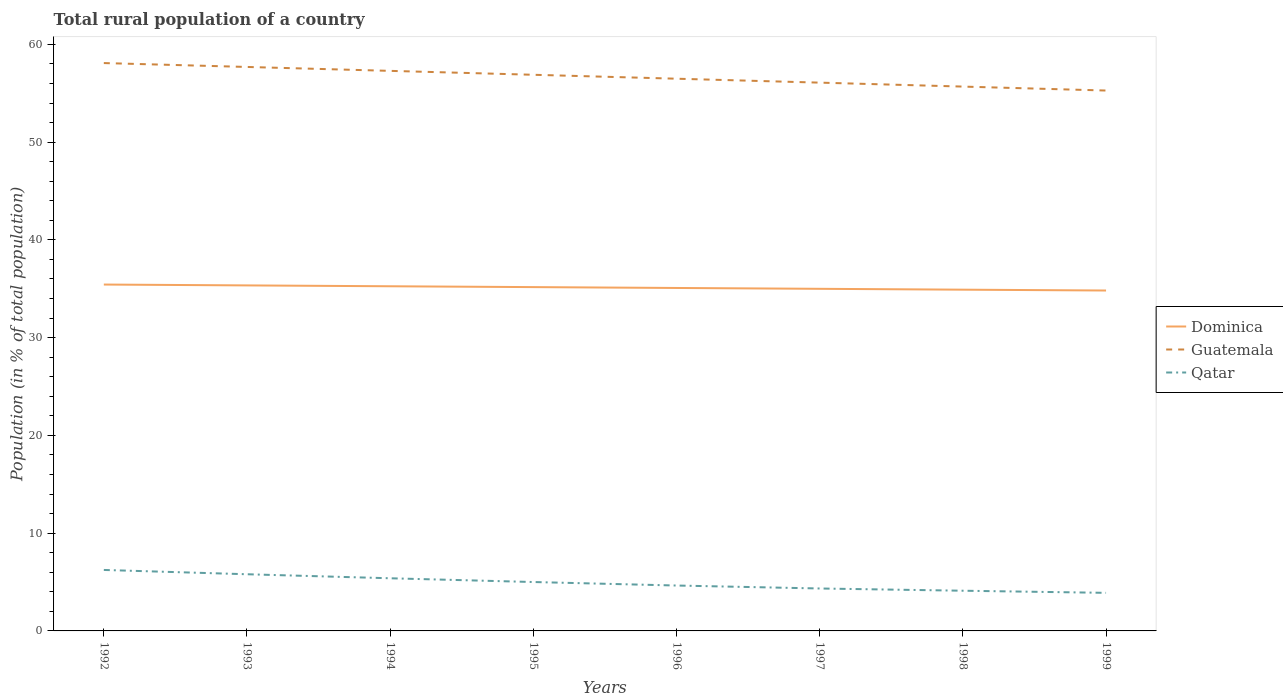How many different coloured lines are there?
Provide a short and direct response. 3. Across all years, what is the maximum rural population in Dominica?
Offer a very short reply. 34.82. In which year was the rural population in Dominica maximum?
Your answer should be compact. 1999. What is the total rural population in Dominica in the graph?
Provide a succinct answer. 0.44. What is the difference between the highest and the second highest rural population in Guatemala?
Provide a succinct answer. 2.81. What is the difference between the highest and the lowest rural population in Qatar?
Make the answer very short. 4. How many lines are there?
Give a very brief answer. 3. How many years are there in the graph?
Ensure brevity in your answer.  8. How many legend labels are there?
Make the answer very short. 3. What is the title of the graph?
Your response must be concise. Total rural population of a country. What is the label or title of the Y-axis?
Give a very brief answer. Population (in % of total population). What is the Population (in % of total population) in Dominica in 1992?
Make the answer very short. 35.43. What is the Population (in % of total population) in Guatemala in 1992?
Ensure brevity in your answer.  58.09. What is the Population (in % of total population) in Qatar in 1992?
Offer a very short reply. 6.24. What is the Population (in % of total population) in Dominica in 1993?
Provide a short and direct response. 35.34. What is the Population (in % of total population) in Guatemala in 1993?
Offer a terse response. 57.69. What is the Population (in % of total population) in Qatar in 1993?
Your answer should be compact. 5.8. What is the Population (in % of total population) in Dominica in 1994?
Make the answer very short. 35.26. What is the Population (in % of total population) of Guatemala in 1994?
Keep it short and to the point. 57.29. What is the Population (in % of total population) in Qatar in 1994?
Keep it short and to the point. 5.39. What is the Population (in % of total population) of Dominica in 1995?
Provide a succinct answer. 35.17. What is the Population (in % of total population) of Guatemala in 1995?
Offer a terse response. 56.89. What is the Population (in % of total population) in Qatar in 1995?
Make the answer very short. 5. What is the Population (in % of total population) of Dominica in 1996?
Provide a short and direct response. 35.08. What is the Population (in % of total population) of Guatemala in 1996?
Offer a very short reply. 56.49. What is the Population (in % of total population) of Qatar in 1996?
Give a very brief answer. 4.64. What is the Population (in % of total population) in Dominica in 1997?
Offer a very short reply. 34.99. What is the Population (in % of total population) in Guatemala in 1997?
Give a very brief answer. 56.09. What is the Population (in % of total population) in Qatar in 1997?
Your answer should be very brief. 4.34. What is the Population (in % of total population) in Dominica in 1998?
Keep it short and to the point. 34.91. What is the Population (in % of total population) in Guatemala in 1998?
Give a very brief answer. 55.68. What is the Population (in % of total population) of Qatar in 1998?
Offer a terse response. 4.11. What is the Population (in % of total population) in Dominica in 1999?
Offer a terse response. 34.82. What is the Population (in % of total population) of Guatemala in 1999?
Give a very brief answer. 55.28. What is the Population (in % of total population) of Qatar in 1999?
Your answer should be very brief. 3.9. Across all years, what is the maximum Population (in % of total population) in Dominica?
Provide a short and direct response. 35.43. Across all years, what is the maximum Population (in % of total population) in Guatemala?
Your answer should be very brief. 58.09. Across all years, what is the maximum Population (in % of total population) in Qatar?
Make the answer very short. 6.24. Across all years, what is the minimum Population (in % of total population) of Dominica?
Your answer should be compact. 34.82. Across all years, what is the minimum Population (in % of total population) in Guatemala?
Make the answer very short. 55.28. Across all years, what is the minimum Population (in % of total population) in Qatar?
Ensure brevity in your answer.  3.9. What is the total Population (in % of total population) of Dominica in the graph?
Make the answer very short. 281.01. What is the total Population (in % of total population) in Guatemala in the graph?
Keep it short and to the point. 453.49. What is the total Population (in % of total population) in Qatar in the graph?
Provide a short and direct response. 39.41. What is the difference between the Population (in % of total population) in Dominica in 1992 and that in 1993?
Your answer should be very brief. 0.09. What is the difference between the Population (in % of total population) of Guatemala in 1992 and that in 1993?
Your answer should be compact. 0.4. What is the difference between the Population (in % of total population) of Qatar in 1992 and that in 1993?
Provide a succinct answer. 0.44. What is the difference between the Population (in % of total population) in Dominica in 1992 and that in 1994?
Provide a succinct answer. 0.17. What is the difference between the Population (in % of total population) of Guatemala in 1992 and that in 1994?
Provide a short and direct response. 0.8. What is the difference between the Population (in % of total population) of Qatar in 1992 and that in 1994?
Your answer should be very brief. 0.85. What is the difference between the Population (in % of total population) of Dominica in 1992 and that in 1995?
Offer a terse response. 0.26. What is the difference between the Population (in % of total population) in Guatemala in 1992 and that in 1995?
Provide a short and direct response. 1.2. What is the difference between the Population (in % of total population) of Qatar in 1992 and that in 1995?
Keep it short and to the point. 1.24. What is the difference between the Population (in % of total population) in Dominica in 1992 and that in 1996?
Your answer should be very brief. 0.35. What is the difference between the Population (in % of total population) in Guatemala in 1992 and that in 1996?
Offer a terse response. 1.6. What is the difference between the Population (in % of total population) of Qatar in 1992 and that in 1996?
Keep it short and to the point. 1.59. What is the difference between the Population (in % of total population) of Dominica in 1992 and that in 1997?
Offer a terse response. 0.44. What is the difference between the Population (in % of total population) of Guatemala in 1992 and that in 1997?
Offer a terse response. 2. What is the difference between the Population (in % of total population) of Qatar in 1992 and that in 1997?
Give a very brief answer. 1.9. What is the difference between the Population (in % of total population) of Dominica in 1992 and that in 1998?
Give a very brief answer. 0.52. What is the difference between the Population (in % of total population) in Guatemala in 1992 and that in 1998?
Ensure brevity in your answer.  2.41. What is the difference between the Population (in % of total population) in Qatar in 1992 and that in 1998?
Your answer should be compact. 2.12. What is the difference between the Population (in % of total population) in Dominica in 1992 and that in 1999?
Give a very brief answer. 0.61. What is the difference between the Population (in % of total population) in Guatemala in 1992 and that in 1999?
Make the answer very short. 2.81. What is the difference between the Population (in % of total population) in Qatar in 1992 and that in 1999?
Provide a short and direct response. 2.34. What is the difference between the Population (in % of total population) in Dominica in 1993 and that in 1994?
Keep it short and to the point. 0.09. What is the difference between the Population (in % of total population) in Qatar in 1993 and that in 1994?
Make the answer very short. 0.41. What is the difference between the Population (in % of total population) of Dominica in 1993 and that in 1995?
Make the answer very short. 0.17. What is the difference between the Population (in % of total population) in Qatar in 1993 and that in 1995?
Your answer should be very brief. 0.8. What is the difference between the Population (in % of total population) in Dominica in 1993 and that in 1996?
Your answer should be very brief. 0.26. What is the difference between the Population (in % of total population) of Guatemala in 1993 and that in 1996?
Give a very brief answer. 1.2. What is the difference between the Population (in % of total population) of Qatar in 1993 and that in 1996?
Your answer should be compact. 1.15. What is the difference between the Population (in % of total population) of Dominica in 1993 and that in 1997?
Provide a short and direct response. 0.35. What is the difference between the Population (in % of total population) in Guatemala in 1993 and that in 1997?
Offer a terse response. 1.6. What is the difference between the Population (in % of total population) in Qatar in 1993 and that in 1997?
Provide a succinct answer. 1.46. What is the difference between the Population (in % of total population) in Dominica in 1993 and that in 1998?
Provide a succinct answer. 0.44. What is the difference between the Population (in % of total population) in Guatemala in 1993 and that in 1998?
Ensure brevity in your answer.  2.01. What is the difference between the Population (in % of total population) of Qatar in 1993 and that in 1998?
Ensure brevity in your answer.  1.69. What is the difference between the Population (in % of total population) of Dominica in 1993 and that in 1999?
Ensure brevity in your answer.  0.52. What is the difference between the Population (in % of total population) of Guatemala in 1993 and that in 1999?
Your answer should be compact. 2.41. What is the difference between the Population (in % of total population) in Qatar in 1993 and that in 1999?
Give a very brief answer. 1.9. What is the difference between the Population (in % of total population) in Dominica in 1994 and that in 1995?
Offer a very short reply. 0.09. What is the difference between the Population (in % of total population) in Guatemala in 1994 and that in 1995?
Offer a terse response. 0.4. What is the difference between the Population (in % of total population) in Qatar in 1994 and that in 1995?
Provide a succinct answer. 0.38. What is the difference between the Population (in % of total population) of Dominica in 1994 and that in 1996?
Make the answer very short. 0.17. What is the difference between the Population (in % of total population) of Guatemala in 1994 and that in 1996?
Offer a terse response. 0.8. What is the difference between the Population (in % of total population) of Qatar in 1994 and that in 1996?
Offer a very short reply. 0.74. What is the difference between the Population (in % of total population) in Dominica in 1994 and that in 1997?
Your response must be concise. 0.26. What is the difference between the Population (in % of total population) of Guatemala in 1994 and that in 1997?
Provide a short and direct response. 1.2. What is the difference between the Population (in % of total population) in Qatar in 1994 and that in 1997?
Offer a very short reply. 1.04. What is the difference between the Population (in % of total population) in Dominica in 1994 and that in 1998?
Provide a short and direct response. 0.35. What is the difference between the Population (in % of total population) in Guatemala in 1994 and that in 1998?
Your response must be concise. 1.61. What is the difference between the Population (in % of total population) of Qatar in 1994 and that in 1998?
Your answer should be compact. 1.27. What is the difference between the Population (in % of total population) in Dominica in 1994 and that in 1999?
Provide a short and direct response. 0.43. What is the difference between the Population (in % of total population) of Guatemala in 1994 and that in 1999?
Keep it short and to the point. 2.01. What is the difference between the Population (in % of total population) of Qatar in 1994 and that in 1999?
Offer a very short reply. 1.49. What is the difference between the Population (in % of total population) of Dominica in 1995 and that in 1996?
Provide a succinct answer. 0.09. What is the difference between the Population (in % of total population) of Guatemala in 1995 and that in 1996?
Offer a very short reply. 0.4. What is the difference between the Population (in % of total population) of Qatar in 1995 and that in 1996?
Provide a succinct answer. 0.36. What is the difference between the Population (in % of total population) in Dominica in 1995 and that in 1997?
Your answer should be very brief. 0.17. What is the difference between the Population (in % of total population) in Guatemala in 1995 and that in 1997?
Your response must be concise. 0.8. What is the difference between the Population (in % of total population) in Qatar in 1995 and that in 1997?
Offer a very short reply. 0.66. What is the difference between the Population (in % of total population) of Dominica in 1995 and that in 1998?
Make the answer very short. 0.26. What is the difference between the Population (in % of total population) in Guatemala in 1995 and that in 1998?
Provide a short and direct response. 1.21. What is the difference between the Population (in % of total population) in Qatar in 1995 and that in 1998?
Offer a terse response. 0.89. What is the difference between the Population (in % of total population) of Dominica in 1995 and that in 1999?
Keep it short and to the point. 0.35. What is the difference between the Population (in % of total population) of Guatemala in 1995 and that in 1999?
Give a very brief answer. 1.61. What is the difference between the Population (in % of total population) in Qatar in 1995 and that in 1999?
Your response must be concise. 1.11. What is the difference between the Population (in % of total population) of Dominica in 1996 and that in 1997?
Offer a terse response. 0.09. What is the difference between the Population (in % of total population) of Guatemala in 1996 and that in 1997?
Keep it short and to the point. 0.4. What is the difference between the Population (in % of total population) of Qatar in 1996 and that in 1997?
Provide a succinct answer. 0.3. What is the difference between the Population (in % of total population) in Dominica in 1996 and that in 1998?
Your response must be concise. 0.17. What is the difference between the Population (in % of total population) in Guatemala in 1996 and that in 1998?
Offer a terse response. 0.81. What is the difference between the Population (in % of total population) of Qatar in 1996 and that in 1998?
Offer a very short reply. 0.53. What is the difference between the Population (in % of total population) of Dominica in 1996 and that in 1999?
Your response must be concise. 0.26. What is the difference between the Population (in % of total population) in Guatemala in 1996 and that in 1999?
Offer a terse response. 1.21. What is the difference between the Population (in % of total population) in Qatar in 1996 and that in 1999?
Your answer should be very brief. 0.75. What is the difference between the Population (in % of total population) in Dominica in 1997 and that in 1998?
Give a very brief answer. 0.09. What is the difference between the Population (in % of total population) in Guatemala in 1997 and that in 1998?
Make the answer very short. 0.4. What is the difference between the Population (in % of total population) of Qatar in 1997 and that in 1998?
Keep it short and to the point. 0.23. What is the difference between the Population (in % of total population) of Dominica in 1997 and that in 1999?
Keep it short and to the point. 0.17. What is the difference between the Population (in % of total population) of Guatemala in 1997 and that in 1999?
Keep it short and to the point. 0.81. What is the difference between the Population (in % of total population) in Qatar in 1997 and that in 1999?
Offer a very short reply. 0.45. What is the difference between the Population (in % of total population) of Dominica in 1998 and that in 1999?
Offer a terse response. 0.09. What is the difference between the Population (in % of total population) in Guatemala in 1998 and that in 1999?
Ensure brevity in your answer.  0.4. What is the difference between the Population (in % of total population) in Qatar in 1998 and that in 1999?
Offer a very short reply. 0.22. What is the difference between the Population (in % of total population) in Dominica in 1992 and the Population (in % of total population) in Guatemala in 1993?
Provide a succinct answer. -22.26. What is the difference between the Population (in % of total population) in Dominica in 1992 and the Population (in % of total population) in Qatar in 1993?
Ensure brevity in your answer.  29.63. What is the difference between the Population (in % of total population) in Guatemala in 1992 and the Population (in % of total population) in Qatar in 1993?
Offer a terse response. 52.29. What is the difference between the Population (in % of total population) in Dominica in 1992 and the Population (in % of total population) in Guatemala in 1994?
Provide a succinct answer. -21.86. What is the difference between the Population (in % of total population) of Dominica in 1992 and the Population (in % of total population) of Qatar in 1994?
Your answer should be compact. 30.05. What is the difference between the Population (in % of total population) in Guatemala in 1992 and the Population (in % of total population) in Qatar in 1994?
Give a very brief answer. 52.7. What is the difference between the Population (in % of total population) of Dominica in 1992 and the Population (in % of total population) of Guatemala in 1995?
Make the answer very short. -21.46. What is the difference between the Population (in % of total population) of Dominica in 1992 and the Population (in % of total population) of Qatar in 1995?
Your response must be concise. 30.43. What is the difference between the Population (in % of total population) in Guatemala in 1992 and the Population (in % of total population) in Qatar in 1995?
Your response must be concise. 53.09. What is the difference between the Population (in % of total population) in Dominica in 1992 and the Population (in % of total population) in Guatemala in 1996?
Make the answer very short. -21.06. What is the difference between the Population (in % of total population) in Dominica in 1992 and the Population (in % of total population) in Qatar in 1996?
Offer a very short reply. 30.79. What is the difference between the Population (in % of total population) in Guatemala in 1992 and the Population (in % of total population) in Qatar in 1996?
Offer a very short reply. 53.44. What is the difference between the Population (in % of total population) of Dominica in 1992 and the Population (in % of total population) of Guatemala in 1997?
Ensure brevity in your answer.  -20.66. What is the difference between the Population (in % of total population) in Dominica in 1992 and the Population (in % of total population) in Qatar in 1997?
Your answer should be very brief. 31.09. What is the difference between the Population (in % of total population) in Guatemala in 1992 and the Population (in % of total population) in Qatar in 1997?
Provide a succinct answer. 53.75. What is the difference between the Population (in % of total population) of Dominica in 1992 and the Population (in % of total population) of Guatemala in 1998?
Offer a very short reply. -20.25. What is the difference between the Population (in % of total population) of Dominica in 1992 and the Population (in % of total population) of Qatar in 1998?
Offer a terse response. 31.32. What is the difference between the Population (in % of total population) in Guatemala in 1992 and the Population (in % of total population) in Qatar in 1998?
Ensure brevity in your answer.  53.98. What is the difference between the Population (in % of total population) of Dominica in 1992 and the Population (in % of total population) of Guatemala in 1999?
Provide a short and direct response. -19.85. What is the difference between the Population (in % of total population) of Dominica in 1992 and the Population (in % of total population) of Qatar in 1999?
Your answer should be very brief. 31.54. What is the difference between the Population (in % of total population) in Guatemala in 1992 and the Population (in % of total population) in Qatar in 1999?
Offer a terse response. 54.19. What is the difference between the Population (in % of total population) in Dominica in 1993 and the Population (in % of total population) in Guatemala in 1994?
Your answer should be very brief. -21.95. What is the difference between the Population (in % of total population) of Dominica in 1993 and the Population (in % of total population) of Qatar in 1994?
Your response must be concise. 29.96. What is the difference between the Population (in % of total population) of Guatemala in 1993 and the Population (in % of total population) of Qatar in 1994?
Provide a short and direct response. 52.3. What is the difference between the Population (in % of total population) of Dominica in 1993 and the Population (in % of total population) of Guatemala in 1995?
Give a very brief answer. -21.55. What is the difference between the Population (in % of total population) in Dominica in 1993 and the Population (in % of total population) in Qatar in 1995?
Ensure brevity in your answer.  30.34. What is the difference between the Population (in % of total population) of Guatemala in 1993 and the Population (in % of total population) of Qatar in 1995?
Make the answer very short. 52.69. What is the difference between the Population (in % of total population) in Dominica in 1993 and the Population (in % of total population) in Guatemala in 1996?
Offer a very short reply. -21.14. What is the difference between the Population (in % of total population) of Dominica in 1993 and the Population (in % of total population) of Qatar in 1996?
Keep it short and to the point. 30.7. What is the difference between the Population (in % of total population) of Guatemala in 1993 and the Population (in % of total population) of Qatar in 1996?
Your response must be concise. 53.05. What is the difference between the Population (in % of total population) in Dominica in 1993 and the Population (in % of total population) in Guatemala in 1997?
Provide a succinct answer. -20.74. What is the difference between the Population (in % of total population) of Dominica in 1993 and the Population (in % of total population) of Qatar in 1997?
Your response must be concise. 31. What is the difference between the Population (in % of total population) of Guatemala in 1993 and the Population (in % of total population) of Qatar in 1997?
Your answer should be very brief. 53.35. What is the difference between the Population (in % of total population) of Dominica in 1993 and the Population (in % of total population) of Guatemala in 1998?
Ensure brevity in your answer.  -20.34. What is the difference between the Population (in % of total population) in Dominica in 1993 and the Population (in % of total population) in Qatar in 1998?
Make the answer very short. 31.23. What is the difference between the Population (in % of total population) of Guatemala in 1993 and the Population (in % of total population) of Qatar in 1998?
Give a very brief answer. 53.58. What is the difference between the Population (in % of total population) of Dominica in 1993 and the Population (in % of total population) of Guatemala in 1999?
Provide a short and direct response. -19.93. What is the difference between the Population (in % of total population) of Dominica in 1993 and the Population (in % of total population) of Qatar in 1999?
Your response must be concise. 31.45. What is the difference between the Population (in % of total population) in Guatemala in 1993 and the Population (in % of total population) in Qatar in 1999?
Your answer should be compact. 53.8. What is the difference between the Population (in % of total population) of Dominica in 1994 and the Population (in % of total population) of Guatemala in 1995?
Your answer should be compact. -21.63. What is the difference between the Population (in % of total population) in Dominica in 1994 and the Population (in % of total population) in Qatar in 1995?
Provide a succinct answer. 30.25. What is the difference between the Population (in % of total population) in Guatemala in 1994 and the Population (in % of total population) in Qatar in 1995?
Your answer should be compact. 52.29. What is the difference between the Population (in % of total population) in Dominica in 1994 and the Population (in % of total population) in Guatemala in 1996?
Offer a very short reply. -21.23. What is the difference between the Population (in % of total population) in Dominica in 1994 and the Population (in % of total population) in Qatar in 1996?
Provide a short and direct response. 30.61. What is the difference between the Population (in % of total population) of Guatemala in 1994 and the Population (in % of total population) of Qatar in 1996?
Make the answer very short. 52.65. What is the difference between the Population (in % of total population) in Dominica in 1994 and the Population (in % of total population) in Guatemala in 1997?
Offer a terse response. -20.83. What is the difference between the Population (in % of total population) in Dominica in 1994 and the Population (in % of total population) in Qatar in 1997?
Provide a succinct answer. 30.91. What is the difference between the Population (in % of total population) in Guatemala in 1994 and the Population (in % of total population) in Qatar in 1997?
Offer a terse response. 52.95. What is the difference between the Population (in % of total population) of Dominica in 1994 and the Population (in % of total population) of Guatemala in 1998?
Provide a short and direct response. -20.43. What is the difference between the Population (in % of total population) in Dominica in 1994 and the Population (in % of total population) in Qatar in 1998?
Your answer should be very brief. 31.14. What is the difference between the Population (in % of total population) of Guatemala in 1994 and the Population (in % of total population) of Qatar in 1998?
Your response must be concise. 53.18. What is the difference between the Population (in % of total population) of Dominica in 1994 and the Population (in % of total population) of Guatemala in 1999?
Your answer should be compact. -20.02. What is the difference between the Population (in % of total population) in Dominica in 1994 and the Population (in % of total population) in Qatar in 1999?
Offer a very short reply. 31.36. What is the difference between the Population (in % of total population) in Guatemala in 1994 and the Population (in % of total population) in Qatar in 1999?
Offer a terse response. 53.4. What is the difference between the Population (in % of total population) in Dominica in 1995 and the Population (in % of total population) in Guatemala in 1996?
Provide a short and direct response. -21.32. What is the difference between the Population (in % of total population) in Dominica in 1995 and the Population (in % of total population) in Qatar in 1996?
Make the answer very short. 30.52. What is the difference between the Population (in % of total population) in Guatemala in 1995 and the Population (in % of total population) in Qatar in 1996?
Give a very brief answer. 52.25. What is the difference between the Population (in % of total population) in Dominica in 1995 and the Population (in % of total population) in Guatemala in 1997?
Provide a succinct answer. -20.92. What is the difference between the Population (in % of total population) in Dominica in 1995 and the Population (in % of total population) in Qatar in 1997?
Give a very brief answer. 30.83. What is the difference between the Population (in % of total population) in Guatemala in 1995 and the Population (in % of total population) in Qatar in 1997?
Your response must be concise. 52.55. What is the difference between the Population (in % of total population) in Dominica in 1995 and the Population (in % of total population) in Guatemala in 1998?
Your response must be concise. -20.51. What is the difference between the Population (in % of total population) of Dominica in 1995 and the Population (in % of total population) of Qatar in 1998?
Your answer should be compact. 31.06. What is the difference between the Population (in % of total population) in Guatemala in 1995 and the Population (in % of total population) in Qatar in 1998?
Your answer should be compact. 52.78. What is the difference between the Population (in % of total population) of Dominica in 1995 and the Population (in % of total population) of Guatemala in 1999?
Make the answer very short. -20.11. What is the difference between the Population (in % of total population) of Dominica in 1995 and the Population (in % of total population) of Qatar in 1999?
Your answer should be very brief. 31.27. What is the difference between the Population (in % of total population) in Guatemala in 1995 and the Population (in % of total population) in Qatar in 1999?
Your response must be concise. 52.99. What is the difference between the Population (in % of total population) in Dominica in 1996 and the Population (in % of total population) in Guatemala in 1997?
Give a very brief answer. -21. What is the difference between the Population (in % of total population) of Dominica in 1996 and the Population (in % of total population) of Qatar in 1997?
Your answer should be very brief. 30.74. What is the difference between the Population (in % of total population) of Guatemala in 1996 and the Population (in % of total population) of Qatar in 1997?
Provide a succinct answer. 52.15. What is the difference between the Population (in % of total population) in Dominica in 1996 and the Population (in % of total population) in Guatemala in 1998?
Give a very brief answer. -20.6. What is the difference between the Population (in % of total population) of Dominica in 1996 and the Population (in % of total population) of Qatar in 1998?
Ensure brevity in your answer.  30.97. What is the difference between the Population (in % of total population) in Guatemala in 1996 and the Population (in % of total population) in Qatar in 1998?
Ensure brevity in your answer.  52.38. What is the difference between the Population (in % of total population) in Dominica in 1996 and the Population (in % of total population) in Guatemala in 1999?
Make the answer very short. -20.2. What is the difference between the Population (in % of total population) of Dominica in 1996 and the Population (in % of total population) of Qatar in 1999?
Your answer should be very brief. 31.19. What is the difference between the Population (in % of total population) of Guatemala in 1996 and the Population (in % of total population) of Qatar in 1999?
Your response must be concise. 52.59. What is the difference between the Population (in % of total population) of Dominica in 1997 and the Population (in % of total population) of Guatemala in 1998?
Your answer should be compact. -20.69. What is the difference between the Population (in % of total population) of Dominica in 1997 and the Population (in % of total population) of Qatar in 1998?
Your answer should be very brief. 30.88. What is the difference between the Population (in % of total population) of Guatemala in 1997 and the Population (in % of total population) of Qatar in 1998?
Keep it short and to the point. 51.97. What is the difference between the Population (in % of total population) of Dominica in 1997 and the Population (in % of total population) of Guatemala in 1999?
Provide a succinct answer. -20.28. What is the difference between the Population (in % of total population) of Dominica in 1997 and the Population (in % of total population) of Qatar in 1999?
Offer a very short reply. 31.1. What is the difference between the Population (in % of total population) in Guatemala in 1997 and the Population (in % of total population) in Qatar in 1999?
Offer a terse response. 52.19. What is the difference between the Population (in % of total population) of Dominica in 1998 and the Population (in % of total population) of Guatemala in 1999?
Provide a succinct answer. -20.37. What is the difference between the Population (in % of total population) in Dominica in 1998 and the Population (in % of total population) in Qatar in 1999?
Your answer should be very brief. 31.01. What is the difference between the Population (in % of total population) of Guatemala in 1998 and the Population (in % of total population) of Qatar in 1999?
Keep it short and to the point. 51.79. What is the average Population (in % of total population) of Dominica per year?
Make the answer very short. 35.13. What is the average Population (in % of total population) in Guatemala per year?
Your response must be concise. 56.69. What is the average Population (in % of total population) of Qatar per year?
Your answer should be very brief. 4.93. In the year 1992, what is the difference between the Population (in % of total population) of Dominica and Population (in % of total population) of Guatemala?
Make the answer very short. -22.66. In the year 1992, what is the difference between the Population (in % of total population) in Dominica and Population (in % of total population) in Qatar?
Provide a short and direct response. 29.19. In the year 1992, what is the difference between the Population (in % of total population) of Guatemala and Population (in % of total population) of Qatar?
Offer a terse response. 51.85. In the year 1993, what is the difference between the Population (in % of total population) in Dominica and Population (in % of total population) in Guatemala?
Make the answer very short. -22.35. In the year 1993, what is the difference between the Population (in % of total population) in Dominica and Population (in % of total population) in Qatar?
Your response must be concise. 29.55. In the year 1993, what is the difference between the Population (in % of total population) of Guatemala and Population (in % of total population) of Qatar?
Ensure brevity in your answer.  51.89. In the year 1994, what is the difference between the Population (in % of total population) of Dominica and Population (in % of total population) of Guatemala?
Provide a succinct answer. -22.03. In the year 1994, what is the difference between the Population (in % of total population) of Dominica and Population (in % of total population) of Qatar?
Your answer should be very brief. 29.87. In the year 1994, what is the difference between the Population (in % of total population) of Guatemala and Population (in % of total population) of Qatar?
Provide a succinct answer. 51.9. In the year 1995, what is the difference between the Population (in % of total population) in Dominica and Population (in % of total population) in Guatemala?
Provide a short and direct response. -21.72. In the year 1995, what is the difference between the Population (in % of total population) of Dominica and Population (in % of total population) of Qatar?
Provide a succinct answer. 30.17. In the year 1995, what is the difference between the Population (in % of total population) in Guatemala and Population (in % of total population) in Qatar?
Offer a terse response. 51.89. In the year 1996, what is the difference between the Population (in % of total population) in Dominica and Population (in % of total population) in Guatemala?
Offer a terse response. -21.41. In the year 1996, what is the difference between the Population (in % of total population) of Dominica and Population (in % of total population) of Qatar?
Your response must be concise. 30.44. In the year 1996, what is the difference between the Population (in % of total population) of Guatemala and Population (in % of total population) of Qatar?
Keep it short and to the point. 51.84. In the year 1997, what is the difference between the Population (in % of total population) in Dominica and Population (in % of total population) in Guatemala?
Give a very brief answer. -21.09. In the year 1997, what is the difference between the Population (in % of total population) in Dominica and Population (in % of total population) in Qatar?
Make the answer very short. 30.65. In the year 1997, what is the difference between the Population (in % of total population) of Guatemala and Population (in % of total population) of Qatar?
Offer a very short reply. 51.74. In the year 1998, what is the difference between the Population (in % of total population) of Dominica and Population (in % of total population) of Guatemala?
Offer a terse response. -20.77. In the year 1998, what is the difference between the Population (in % of total population) in Dominica and Population (in % of total population) in Qatar?
Give a very brief answer. 30.8. In the year 1998, what is the difference between the Population (in % of total population) in Guatemala and Population (in % of total population) in Qatar?
Keep it short and to the point. 51.57. In the year 1999, what is the difference between the Population (in % of total population) in Dominica and Population (in % of total population) in Guatemala?
Give a very brief answer. -20.46. In the year 1999, what is the difference between the Population (in % of total population) of Dominica and Population (in % of total population) of Qatar?
Give a very brief answer. 30.93. In the year 1999, what is the difference between the Population (in % of total population) of Guatemala and Population (in % of total population) of Qatar?
Provide a succinct answer. 51.38. What is the ratio of the Population (in % of total population) in Dominica in 1992 to that in 1993?
Offer a terse response. 1. What is the ratio of the Population (in % of total population) of Guatemala in 1992 to that in 1993?
Provide a short and direct response. 1.01. What is the ratio of the Population (in % of total population) in Qatar in 1992 to that in 1993?
Ensure brevity in your answer.  1.08. What is the ratio of the Population (in % of total population) in Guatemala in 1992 to that in 1994?
Offer a terse response. 1.01. What is the ratio of the Population (in % of total population) of Qatar in 1992 to that in 1994?
Provide a succinct answer. 1.16. What is the ratio of the Population (in % of total population) of Dominica in 1992 to that in 1995?
Provide a succinct answer. 1.01. What is the ratio of the Population (in % of total population) in Guatemala in 1992 to that in 1995?
Make the answer very short. 1.02. What is the ratio of the Population (in % of total population) in Qatar in 1992 to that in 1995?
Offer a terse response. 1.25. What is the ratio of the Population (in % of total population) of Dominica in 1992 to that in 1996?
Provide a succinct answer. 1.01. What is the ratio of the Population (in % of total population) of Guatemala in 1992 to that in 1996?
Ensure brevity in your answer.  1.03. What is the ratio of the Population (in % of total population) of Qatar in 1992 to that in 1996?
Ensure brevity in your answer.  1.34. What is the ratio of the Population (in % of total population) in Dominica in 1992 to that in 1997?
Offer a terse response. 1.01. What is the ratio of the Population (in % of total population) of Guatemala in 1992 to that in 1997?
Offer a very short reply. 1.04. What is the ratio of the Population (in % of total population) in Qatar in 1992 to that in 1997?
Offer a very short reply. 1.44. What is the ratio of the Population (in % of total population) of Guatemala in 1992 to that in 1998?
Your answer should be very brief. 1.04. What is the ratio of the Population (in % of total population) in Qatar in 1992 to that in 1998?
Offer a terse response. 1.52. What is the ratio of the Population (in % of total population) of Dominica in 1992 to that in 1999?
Your response must be concise. 1.02. What is the ratio of the Population (in % of total population) in Guatemala in 1992 to that in 1999?
Keep it short and to the point. 1.05. What is the ratio of the Population (in % of total population) in Qatar in 1992 to that in 1999?
Give a very brief answer. 1.6. What is the ratio of the Population (in % of total population) of Guatemala in 1993 to that in 1994?
Offer a terse response. 1.01. What is the ratio of the Population (in % of total population) of Qatar in 1993 to that in 1994?
Ensure brevity in your answer.  1.08. What is the ratio of the Population (in % of total population) in Guatemala in 1993 to that in 1995?
Give a very brief answer. 1.01. What is the ratio of the Population (in % of total population) in Qatar in 1993 to that in 1995?
Your answer should be compact. 1.16. What is the ratio of the Population (in % of total population) of Dominica in 1993 to that in 1996?
Your answer should be compact. 1.01. What is the ratio of the Population (in % of total population) in Guatemala in 1993 to that in 1996?
Offer a terse response. 1.02. What is the ratio of the Population (in % of total population) in Qatar in 1993 to that in 1996?
Provide a succinct answer. 1.25. What is the ratio of the Population (in % of total population) of Guatemala in 1993 to that in 1997?
Your answer should be compact. 1.03. What is the ratio of the Population (in % of total population) of Qatar in 1993 to that in 1997?
Your answer should be compact. 1.34. What is the ratio of the Population (in % of total population) in Dominica in 1993 to that in 1998?
Your response must be concise. 1.01. What is the ratio of the Population (in % of total population) of Guatemala in 1993 to that in 1998?
Your answer should be very brief. 1.04. What is the ratio of the Population (in % of total population) of Qatar in 1993 to that in 1998?
Make the answer very short. 1.41. What is the ratio of the Population (in % of total population) in Guatemala in 1993 to that in 1999?
Provide a short and direct response. 1.04. What is the ratio of the Population (in % of total population) of Qatar in 1993 to that in 1999?
Your answer should be compact. 1.49. What is the ratio of the Population (in % of total population) in Qatar in 1994 to that in 1995?
Make the answer very short. 1.08. What is the ratio of the Population (in % of total population) in Guatemala in 1994 to that in 1996?
Ensure brevity in your answer.  1.01. What is the ratio of the Population (in % of total population) in Qatar in 1994 to that in 1996?
Provide a short and direct response. 1.16. What is the ratio of the Population (in % of total population) in Dominica in 1994 to that in 1997?
Your response must be concise. 1.01. What is the ratio of the Population (in % of total population) in Guatemala in 1994 to that in 1997?
Keep it short and to the point. 1.02. What is the ratio of the Population (in % of total population) in Qatar in 1994 to that in 1997?
Your response must be concise. 1.24. What is the ratio of the Population (in % of total population) in Guatemala in 1994 to that in 1998?
Make the answer very short. 1.03. What is the ratio of the Population (in % of total population) of Qatar in 1994 to that in 1998?
Keep it short and to the point. 1.31. What is the ratio of the Population (in % of total population) in Dominica in 1994 to that in 1999?
Keep it short and to the point. 1.01. What is the ratio of the Population (in % of total population) of Guatemala in 1994 to that in 1999?
Provide a succinct answer. 1.04. What is the ratio of the Population (in % of total population) of Qatar in 1994 to that in 1999?
Give a very brief answer. 1.38. What is the ratio of the Population (in % of total population) in Guatemala in 1995 to that in 1996?
Ensure brevity in your answer.  1.01. What is the ratio of the Population (in % of total population) in Qatar in 1995 to that in 1996?
Keep it short and to the point. 1.08. What is the ratio of the Population (in % of total population) of Guatemala in 1995 to that in 1997?
Offer a terse response. 1.01. What is the ratio of the Population (in % of total population) in Qatar in 1995 to that in 1997?
Your response must be concise. 1.15. What is the ratio of the Population (in % of total population) in Dominica in 1995 to that in 1998?
Keep it short and to the point. 1.01. What is the ratio of the Population (in % of total population) in Guatemala in 1995 to that in 1998?
Your answer should be compact. 1.02. What is the ratio of the Population (in % of total population) of Qatar in 1995 to that in 1998?
Provide a succinct answer. 1.22. What is the ratio of the Population (in % of total population) in Guatemala in 1995 to that in 1999?
Make the answer very short. 1.03. What is the ratio of the Population (in % of total population) in Qatar in 1995 to that in 1999?
Keep it short and to the point. 1.28. What is the ratio of the Population (in % of total population) in Dominica in 1996 to that in 1997?
Ensure brevity in your answer.  1. What is the ratio of the Population (in % of total population) in Guatemala in 1996 to that in 1997?
Your answer should be very brief. 1.01. What is the ratio of the Population (in % of total population) of Qatar in 1996 to that in 1997?
Your answer should be compact. 1.07. What is the ratio of the Population (in % of total population) of Dominica in 1996 to that in 1998?
Offer a terse response. 1. What is the ratio of the Population (in % of total population) of Guatemala in 1996 to that in 1998?
Ensure brevity in your answer.  1.01. What is the ratio of the Population (in % of total population) in Qatar in 1996 to that in 1998?
Provide a succinct answer. 1.13. What is the ratio of the Population (in % of total population) in Dominica in 1996 to that in 1999?
Make the answer very short. 1.01. What is the ratio of the Population (in % of total population) in Guatemala in 1996 to that in 1999?
Your response must be concise. 1.02. What is the ratio of the Population (in % of total population) in Qatar in 1996 to that in 1999?
Offer a very short reply. 1.19. What is the ratio of the Population (in % of total population) in Guatemala in 1997 to that in 1998?
Your answer should be very brief. 1.01. What is the ratio of the Population (in % of total population) in Qatar in 1997 to that in 1998?
Offer a very short reply. 1.06. What is the ratio of the Population (in % of total population) in Dominica in 1997 to that in 1999?
Your answer should be very brief. 1. What is the ratio of the Population (in % of total population) in Guatemala in 1997 to that in 1999?
Make the answer very short. 1.01. What is the ratio of the Population (in % of total population) in Qatar in 1997 to that in 1999?
Make the answer very short. 1.11. What is the ratio of the Population (in % of total population) in Dominica in 1998 to that in 1999?
Provide a short and direct response. 1. What is the ratio of the Population (in % of total population) in Guatemala in 1998 to that in 1999?
Offer a very short reply. 1.01. What is the ratio of the Population (in % of total population) in Qatar in 1998 to that in 1999?
Provide a short and direct response. 1.06. What is the difference between the highest and the second highest Population (in % of total population) in Dominica?
Your response must be concise. 0.09. What is the difference between the highest and the second highest Population (in % of total population) in Guatemala?
Keep it short and to the point. 0.4. What is the difference between the highest and the second highest Population (in % of total population) of Qatar?
Offer a terse response. 0.44. What is the difference between the highest and the lowest Population (in % of total population) in Dominica?
Offer a very short reply. 0.61. What is the difference between the highest and the lowest Population (in % of total population) of Guatemala?
Your answer should be compact. 2.81. What is the difference between the highest and the lowest Population (in % of total population) in Qatar?
Provide a succinct answer. 2.34. 